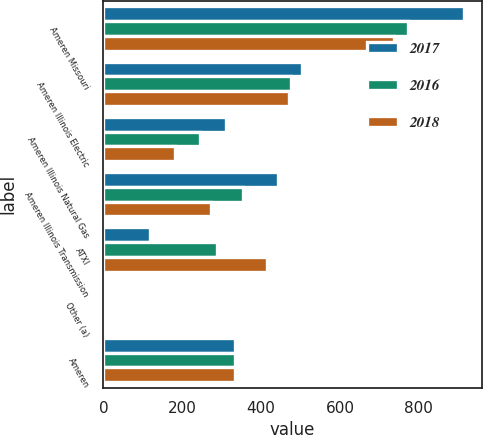<chart> <loc_0><loc_0><loc_500><loc_500><stacked_bar_chart><ecel><fcel>Ameren Missouri<fcel>Ameren Illinois Electric<fcel>Ameren Illinois Natural Gas<fcel>Ameren Illinois Transmission<fcel>ATXI<fcel>Other (a)<fcel>Ameren<nl><fcel>2017<fcel>914<fcel>503<fcel>311<fcel>444<fcel>118<fcel>4<fcel>333<nl><fcel>2016<fcel>773<fcel>476<fcel>245<fcel>355<fcel>289<fcel>6<fcel>333<nl><fcel>2018<fcel>738<fcel>470<fcel>181<fcel>273<fcel>416<fcel>2<fcel>333<nl></chart> 